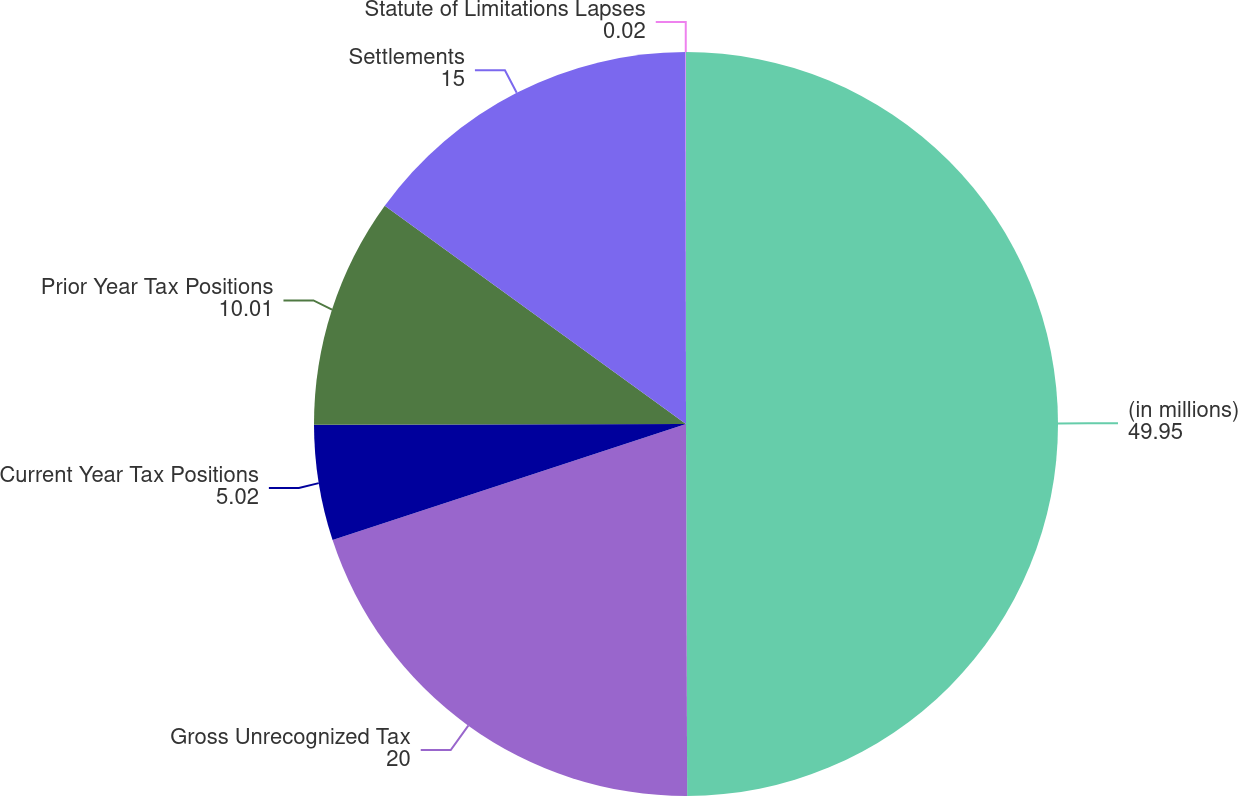Convert chart to OTSL. <chart><loc_0><loc_0><loc_500><loc_500><pie_chart><fcel>(in millions)<fcel>Gross Unrecognized Tax<fcel>Current Year Tax Positions<fcel>Prior Year Tax Positions<fcel>Settlements<fcel>Statute of Limitations Lapses<nl><fcel>49.95%<fcel>20.0%<fcel>5.02%<fcel>10.01%<fcel>15.0%<fcel>0.02%<nl></chart> 